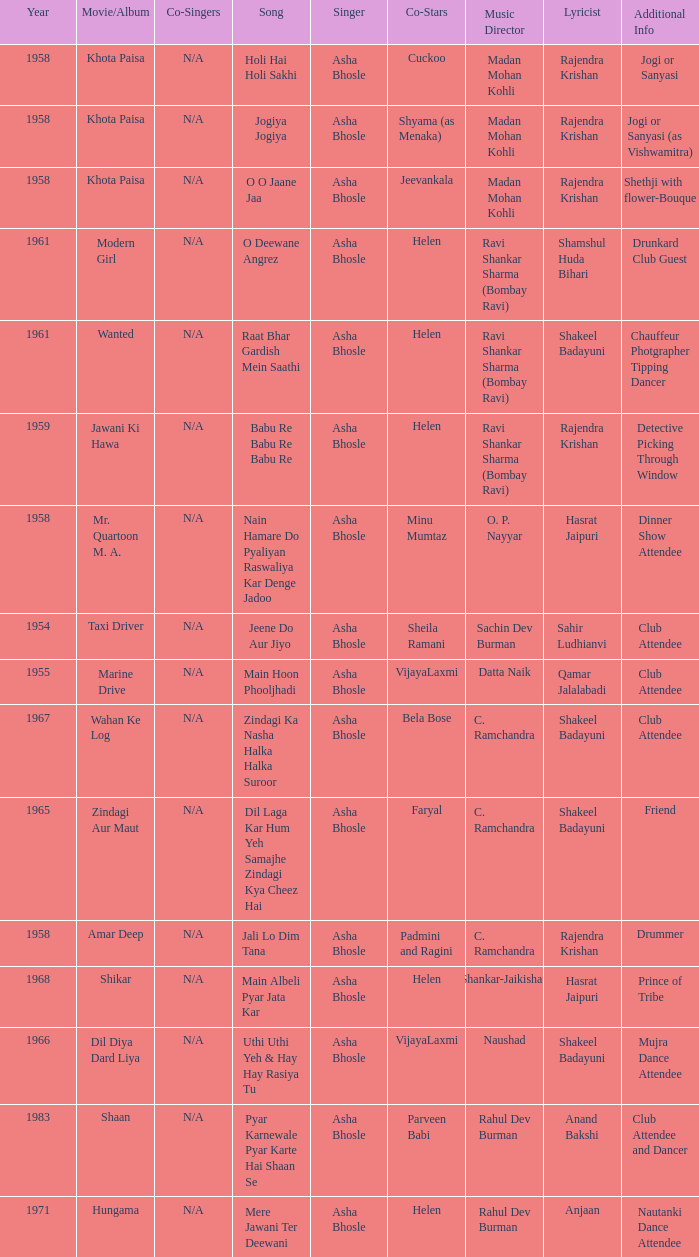What year did Naushad Direct the Music? 1966.0. 